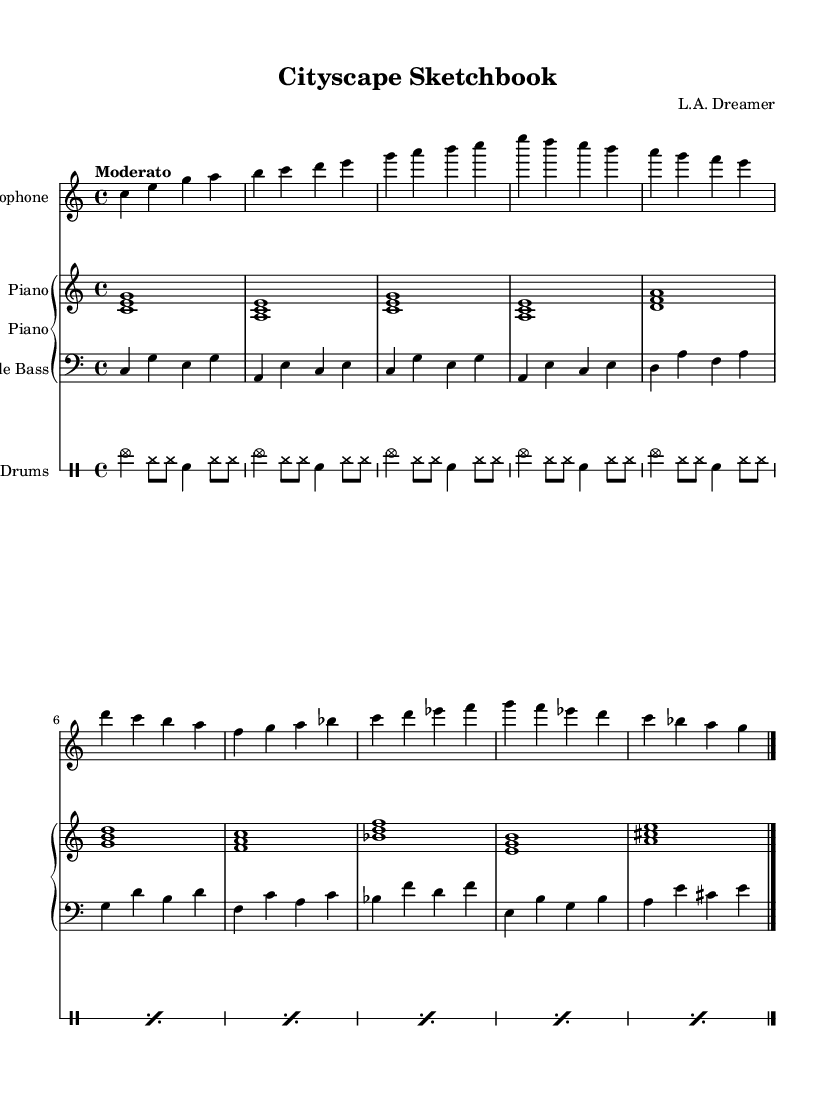What is the key signature of this music? The key signature is C major, which is indicated by the absence of sharps and flats at the beginning of the staff.
Answer: C major What is the time signature of this music? The time signature is 4/4, which can be seen as four beats in each measure, and it is specified at the beginning of the score.
Answer: 4/4 What is the tempo marking for this piece? The tempo marking is "Moderato", indicating a moderate pace for the piece. This is specified near the beginning of the score.
Answer: Moderato How many measures are there in the saxophone part? The saxophone part consists of 8 measures, as indicated by the vertical bar lines separating each measure.
Answer: 8 Which instrument is playing a bass clef? The Double Bass is indicated as playing in the bass clef, which is shown by the clef symbol at the beginning of its staff.
Answer: Double Bass What kind of chords are primarily used in the piano part? The piano part primarily uses triads, as evident from the three-note chords that appear throughout the part.
Answer: Triads What is the rhythmic pattern used in the drums part? The rhythmic pattern predominantly consists of cymbals and hi-hat strikes with snare hits, creating a consistent jazz rhythm.
Answer: Jazz rhythm 